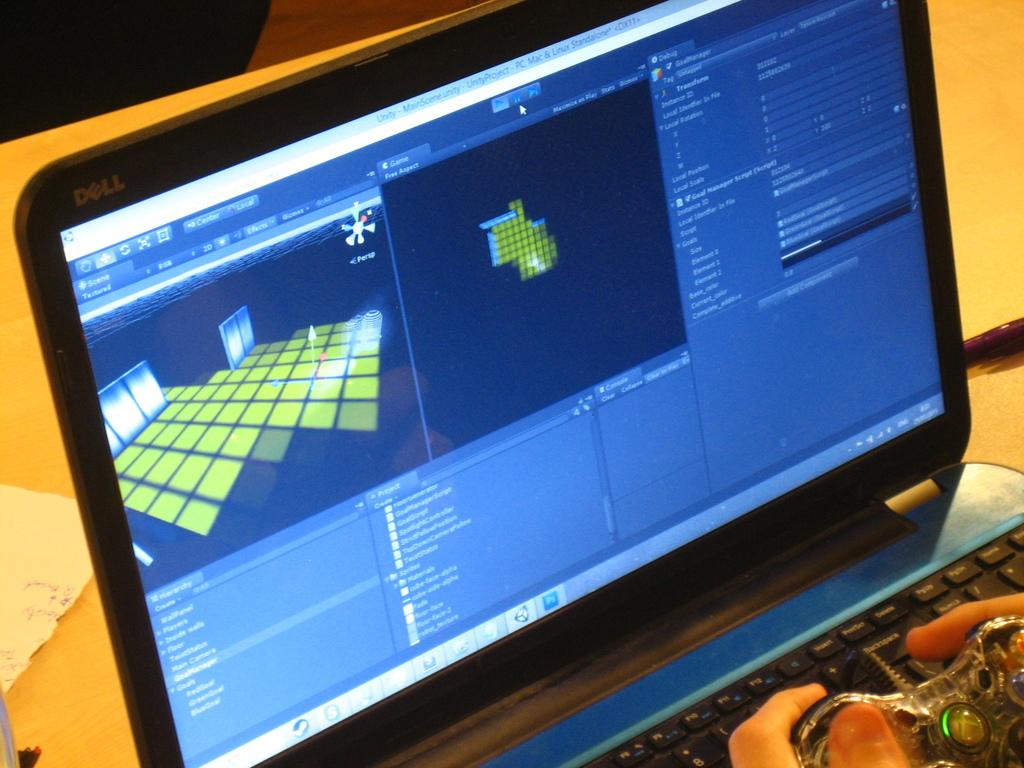What electronic device is present in the image? There is a laptop in the image. What is the person's hand holding in the image? The person's hand is holding an object in the image. What can be seen behind the laptop and the person's hand? The background of the image is visible. What type of produce is being weighed on the scale in the image? There is no scale or produce present in the image; it only features a laptop and a person's hand holding an object. 